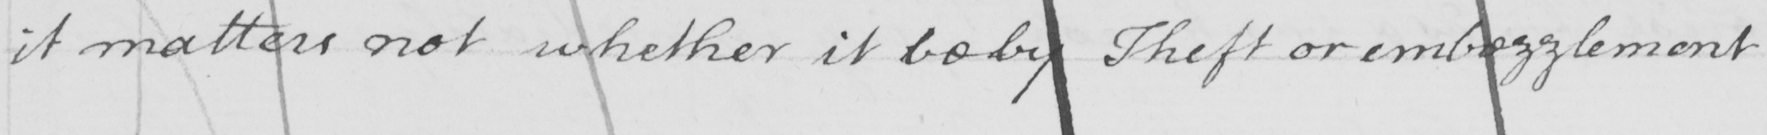What is written in this line of handwriting? it matters not whether it be by Theft or embezzlement 